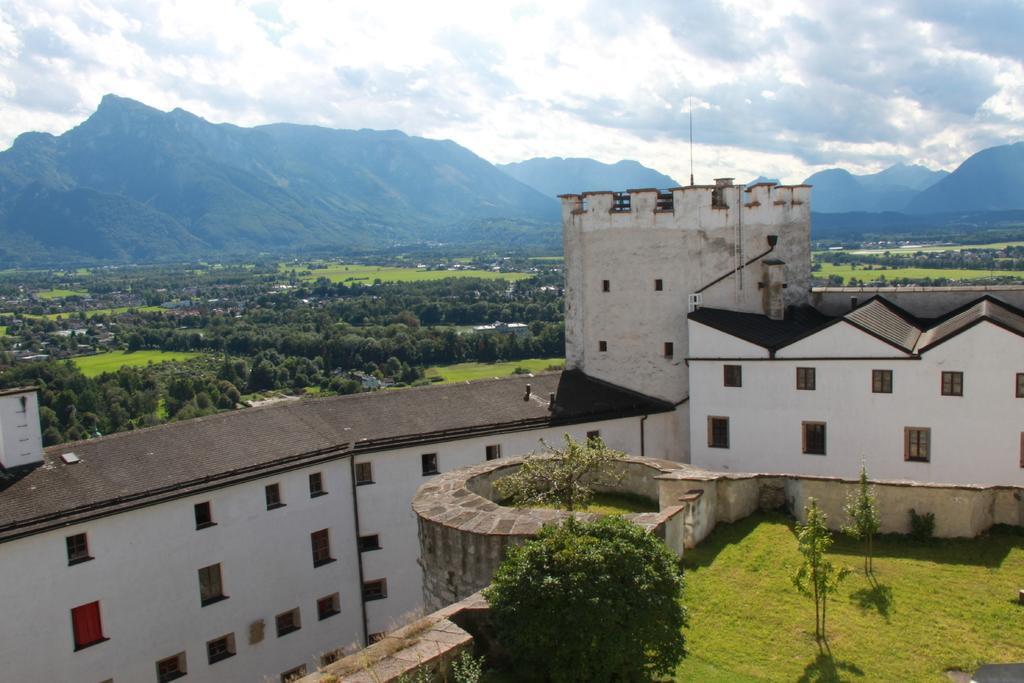Please provide a concise description of this image. In the image we can see a building and these are the windows of the building. We can even see there are many trees around. Here we can see grass, plant, mountains and a cloudy sky. 